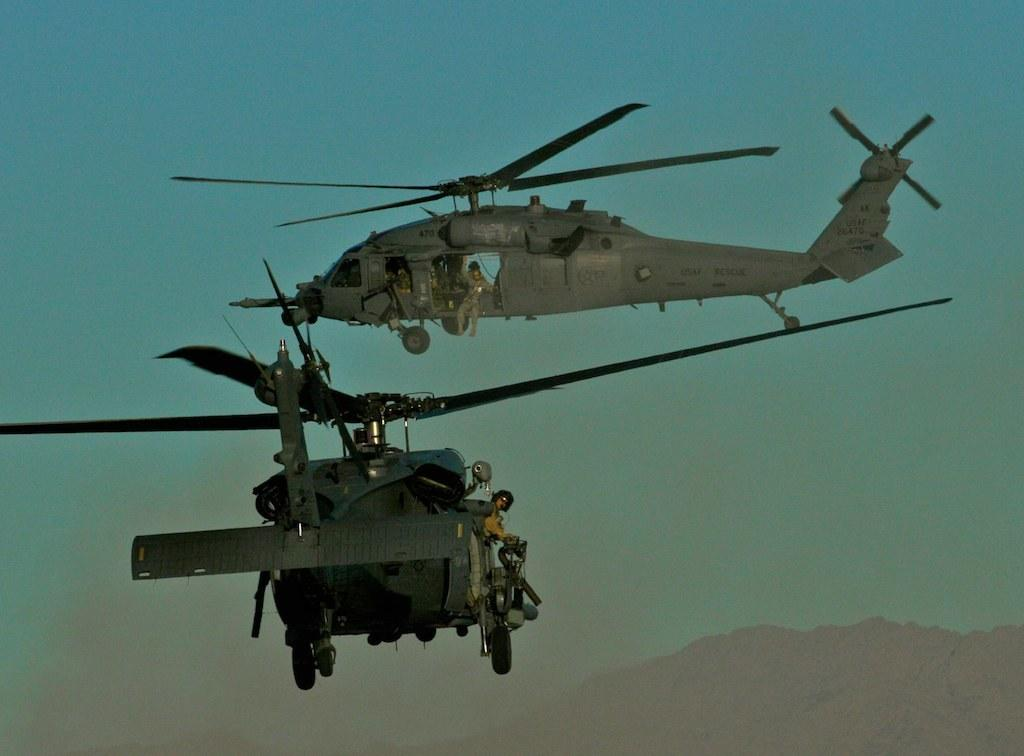How many aircrafts can be seen in the image? There are two aircrafts in the image. What are the aircrafts doing in the image? The aircrafts are in the air. What type of geographical feature is visible in the image? There are mountains visible in the image. What is the color of the sky in the background? The sky is blue in the background. When might this image have been taken? The image is likely taken during the day, as the sky is blue and the aircrafts are in the air. Can you see any pigs walking on the mountains in the image? No, there are no pigs visible in the image, and the mountains are not depicted as having any animals walking on them. 